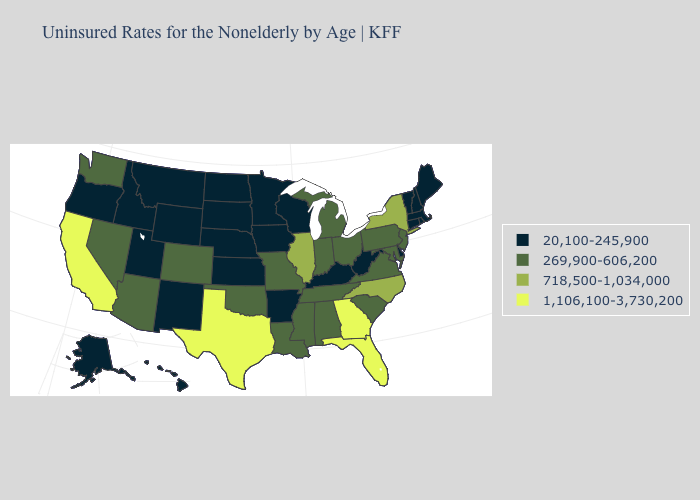What is the value of Nevada?
Write a very short answer. 269,900-606,200. Which states have the highest value in the USA?
Give a very brief answer. California, Florida, Georgia, Texas. Does Illinois have a lower value than Georgia?
Be succinct. Yes. Does Texas have the highest value in the USA?
Write a very short answer. Yes. Among the states that border Tennessee , does Arkansas have the lowest value?
Answer briefly. Yes. Among the states that border Alabama , does Florida have the lowest value?
Quick response, please. No. Which states hav the highest value in the West?
Concise answer only. California. What is the highest value in the USA?
Answer briefly. 1,106,100-3,730,200. Does Kansas have the same value as Oklahoma?
Keep it brief. No. What is the highest value in the USA?
Keep it brief. 1,106,100-3,730,200. Which states have the lowest value in the Northeast?
Keep it brief. Connecticut, Maine, Massachusetts, New Hampshire, Rhode Island, Vermont. Among the states that border Kansas , which have the lowest value?
Be succinct. Nebraska. Among the states that border Nebraska , which have the highest value?
Quick response, please. Colorado, Missouri. What is the value of New Hampshire?
Quick response, please. 20,100-245,900. What is the highest value in the USA?
Quick response, please. 1,106,100-3,730,200. 